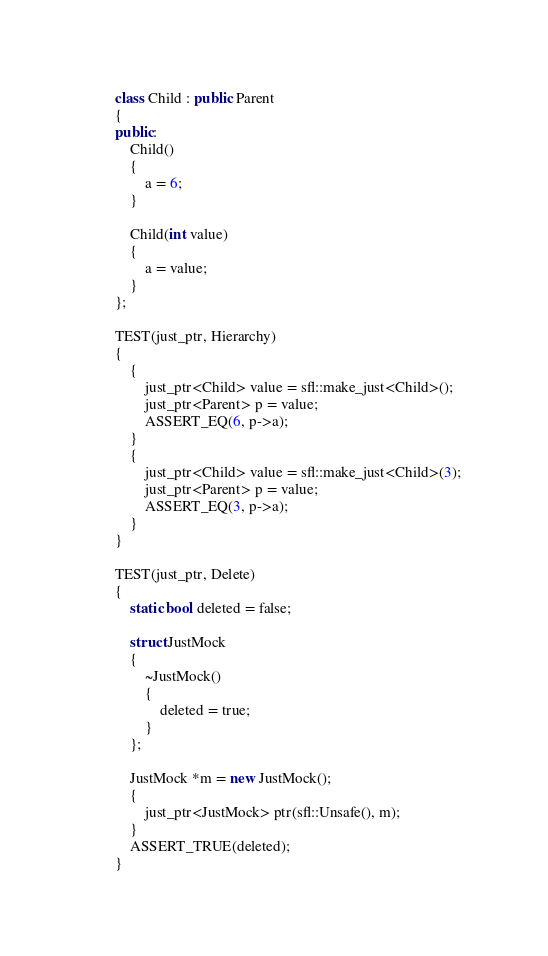<code> <loc_0><loc_0><loc_500><loc_500><_C++_>class Child : public Parent
{
public:
	Child()
	{
		a = 6;
	}

	Child(int value)
	{
		a = value;
	}
};

TEST(just_ptr, Hierarchy)
{
	{
		just_ptr<Child> value = sfl::make_just<Child>();
		just_ptr<Parent> p = value;
		ASSERT_EQ(6, p->a);
	}
	{
		just_ptr<Child> value = sfl::make_just<Child>(3);
		just_ptr<Parent> p = value;
		ASSERT_EQ(3, p->a);
	}
}

TEST(just_ptr, Delete)
{
	static bool deleted = false;

	struct JustMock
	{
		~JustMock()
		{
			deleted = true;
		}
	};

	JustMock *m = new JustMock();
	{
		just_ptr<JustMock> ptr(sfl::Unsafe(), m);
	}
	ASSERT_TRUE(deleted);
}</code> 